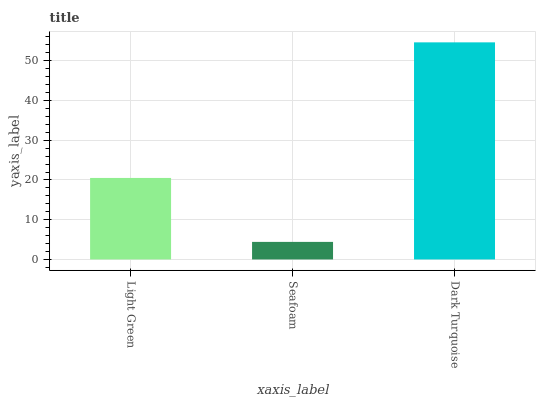Is Dark Turquoise the minimum?
Answer yes or no. No. Is Seafoam the maximum?
Answer yes or no. No. Is Dark Turquoise greater than Seafoam?
Answer yes or no. Yes. Is Seafoam less than Dark Turquoise?
Answer yes or no. Yes. Is Seafoam greater than Dark Turquoise?
Answer yes or no. No. Is Dark Turquoise less than Seafoam?
Answer yes or no. No. Is Light Green the high median?
Answer yes or no. Yes. Is Light Green the low median?
Answer yes or no. Yes. Is Dark Turquoise the high median?
Answer yes or no. No. Is Dark Turquoise the low median?
Answer yes or no. No. 